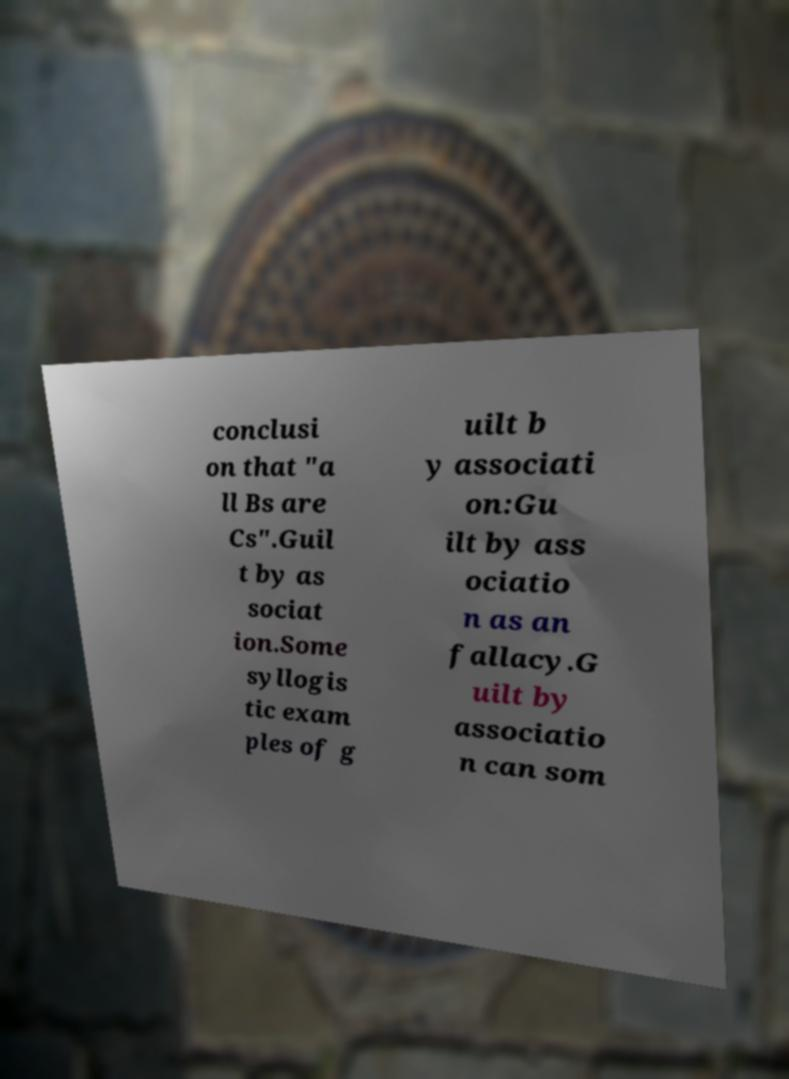Please identify and transcribe the text found in this image. conclusi on that "a ll Bs are Cs".Guil t by as sociat ion.Some syllogis tic exam ples of g uilt b y associati on:Gu ilt by ass ociatio n as an fallacy.G uilt by associatio n can som 